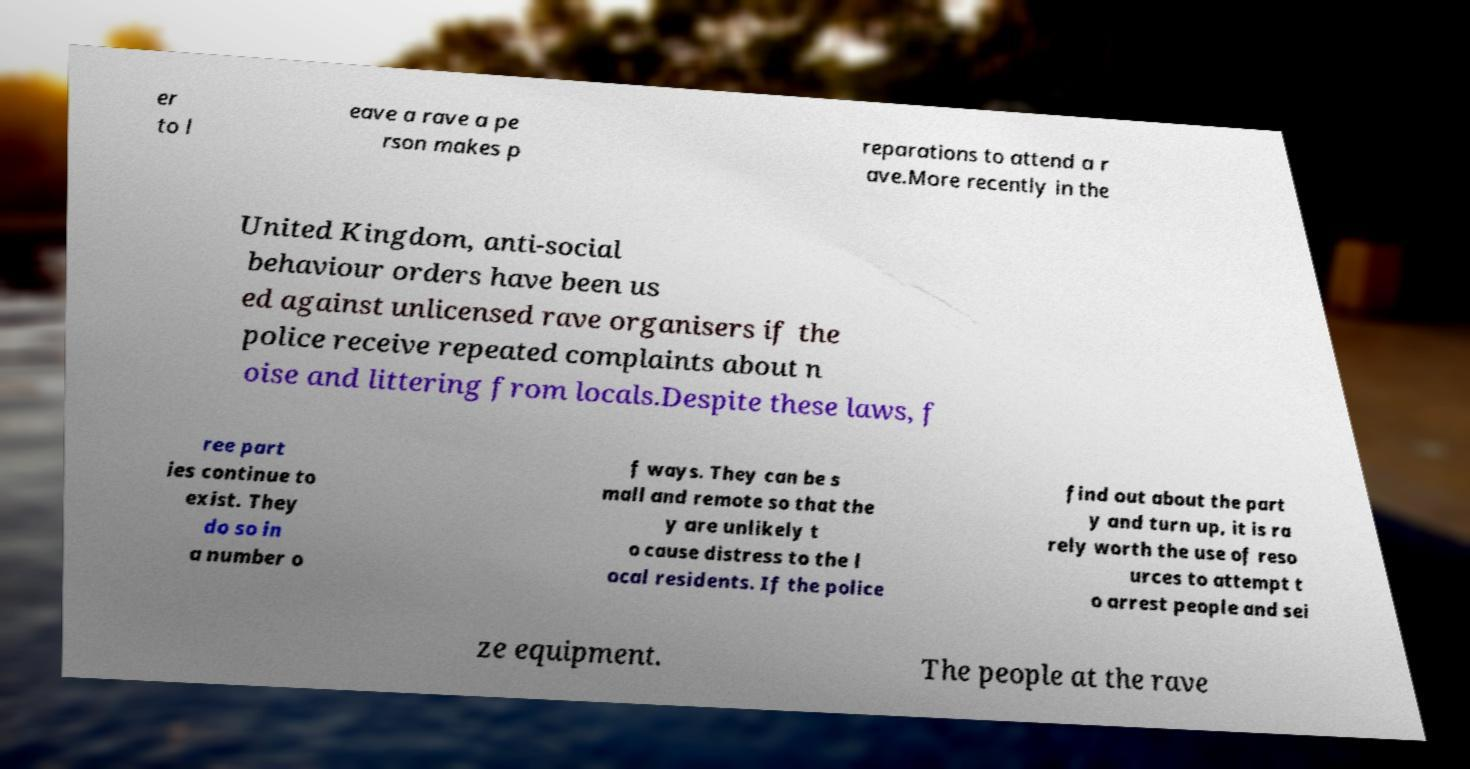Please identify and transcribe the text found in this image. er to l eave a rave a pe rson makes p reparations to attend a r ave.More recently in the United Kingdom, anti-social behaviour orders have been us ed against unlicensed rave organisers if the police receive repeated complaints about n oise and littering from locals.Despite these laws, f ree part ies continue to exist. They do so in a number o f ways. They can be s mall and remote so that the y are unlikely t o cause distress to the l ocal residents. If the police find out about the part y and turn up, it is ra rely worth the use of reso urces to attempt t o arrest people and sei ze equipment. The people at the rave 